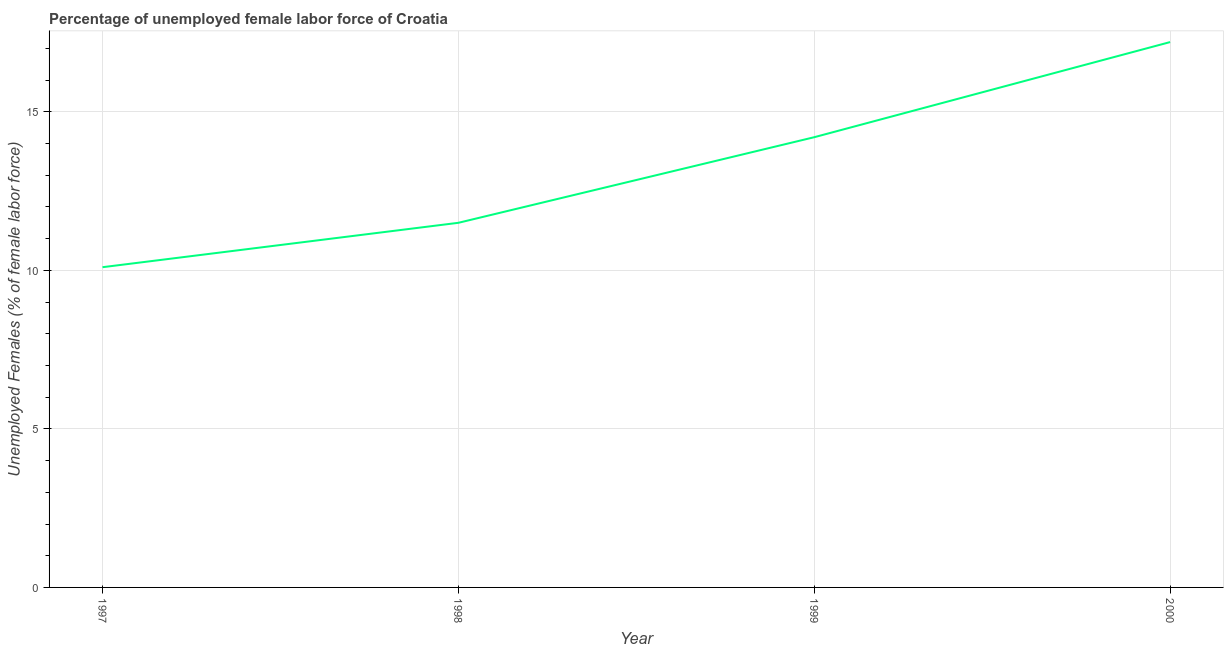What is the total unemployed female labour force in 1997?
Offer a very short reply. 10.1. Across all years, what is the maximum total unemployed female labour force?
Your response must be concise. 17.2. Across all years, what is the minimum total unemployed female labour force?
Offer a terse response. 10.1. In which year was the total unemployed female labour force maximum?
Provide a succinct answer. 2000. What is the sum of the total unemployed female labour force?
Offer a very short reply. 53. What is the difference between the total unemployed female labour force in 1999 and 2000?
Provide a short and direct response. -3. What is the average total unemployed female labour force per year?
Offer a very short reply. 13.25. What is the median total unemployed female labour force?
Keep it short and to the point. 12.85. Do a majority of the years between 1997 and 2000 (inclusive) have total unemployed female labour force greater than 16 %?
Give a very brief answer. No. What is the ratio of the total unemployed female labour force in 1997 to that in 2000?
Offer a very short reply. 0.59. Is the total unemployed female labour force in 1999 less than that in 2000?
Make the answer very short. Yes. Is the difference between the total unemployed female labour force in 1997 and 2000 greater than the difference between any two years?
Your response must be concise. Yes. What is the difference between the highest and the second highest total unemployed female labour force?
Make the answer very short. 3. What is the difference between the highest and the lowest total unemployed female labour force?
Offer a very short reply. 7.1. How many lines are there?
Offer a terse response. 1. How many years are there in the graph?
Your answer should be compact. 4. What is the difference between two consecutive major ticks on the Y-axis?
Provide a succinct answer. 5. Are the values on the major ticks of Y-axis written in scientific E-notation?
Ensure brevity in your answer.  No. Does the graph contain any zero values?
Your response must be concise. No. Does the graph contain grids?
Offer a very short reply. Yes. What is the title of the graph?
Offer a terse response. Percentage of unemployed female labor force of Croatia. What is the label or title of the X-axis?
Your response must be concise. Year. What is the label or title of the Y-axis?
Keep it short and to the point. Unemployed Females (% of female labor force). What is the Unemployed Females (% of female labor force) of 1997?
Your answer should be compact. 10.1. What is the Unemployed Females (% of female labor force) of 1999?
Ensure brevity in your answer.  14.2. What is the Unemployed Females (% of female labor force) of 2000?
Offer a terse response. 17.2. What is the difference between the Unemployed Females (% of female labor force) in 1997 and 2000?
Offer a terse response. -7.1. What is the difference between the Unemployed Females (% of female labor force) in 1998 and 2000?
Your answer should be very brief. -5.7. What is the difference between the Unemployed Females (% of female labor force) in 1999 and 2000?
Give a very brief answer. -3. What is the ratio of the Unemployed Females (% of female labor force) in 1997 to that in 1998?
Your answer should be very brief. 0.88. What is the ratio of the Unemployed Females (% of female labor force) in 1997 to that in 1999?
Your answer should be compact. 0.71. What is the ratio of the Unemployed Females (% of female labor force) in 1997 to that in 2000?
Keep it short and to the point. 0.59. What is the ratio of the Unemployed Females (% of female labor force) in 1998 to that in 1999?
Your answer should be compact. 0.81. What is the ratio of the Unemployed Females (% of female labor force) in 1998 to that in 2000?
Your answer should be very brief. 0.67. What is the ratio of the Unemployed Females (% of female labor force) in 1999 to that in 2000?
Offer a very short reply. 0.83. 